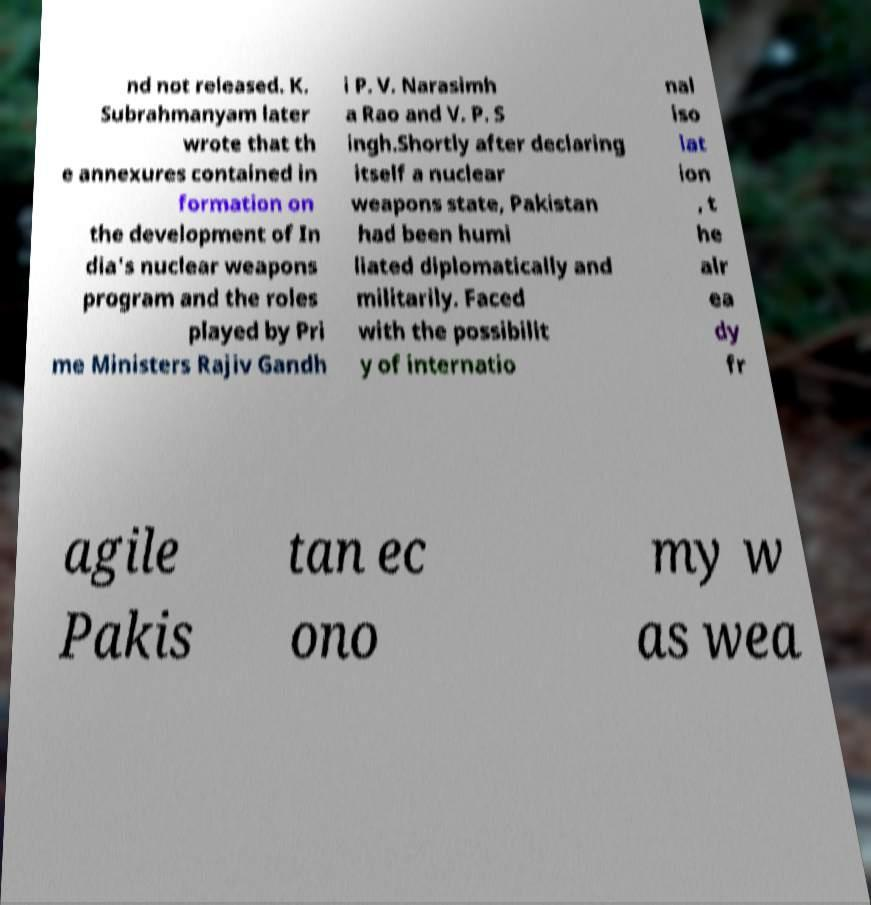Please identify and transcribe the text found in this image. nd not released. K. Subrahmanyam later wrote that th e annexures contained in formation on the development of In dia's nuclear weapons program and the roles played by Pri me Ministers Rajiv Gandh i P. V. Narasimh a Rao and V. P. S ingh.Shortly after declaring itself a nuclear weapons state, Pakistan had been humi liated diplomatically and militarily. Faced with the possibilit y of internatio nal iso lat ion , t he alr ea dy fr agile Pakis tan ec ono my w as wea 